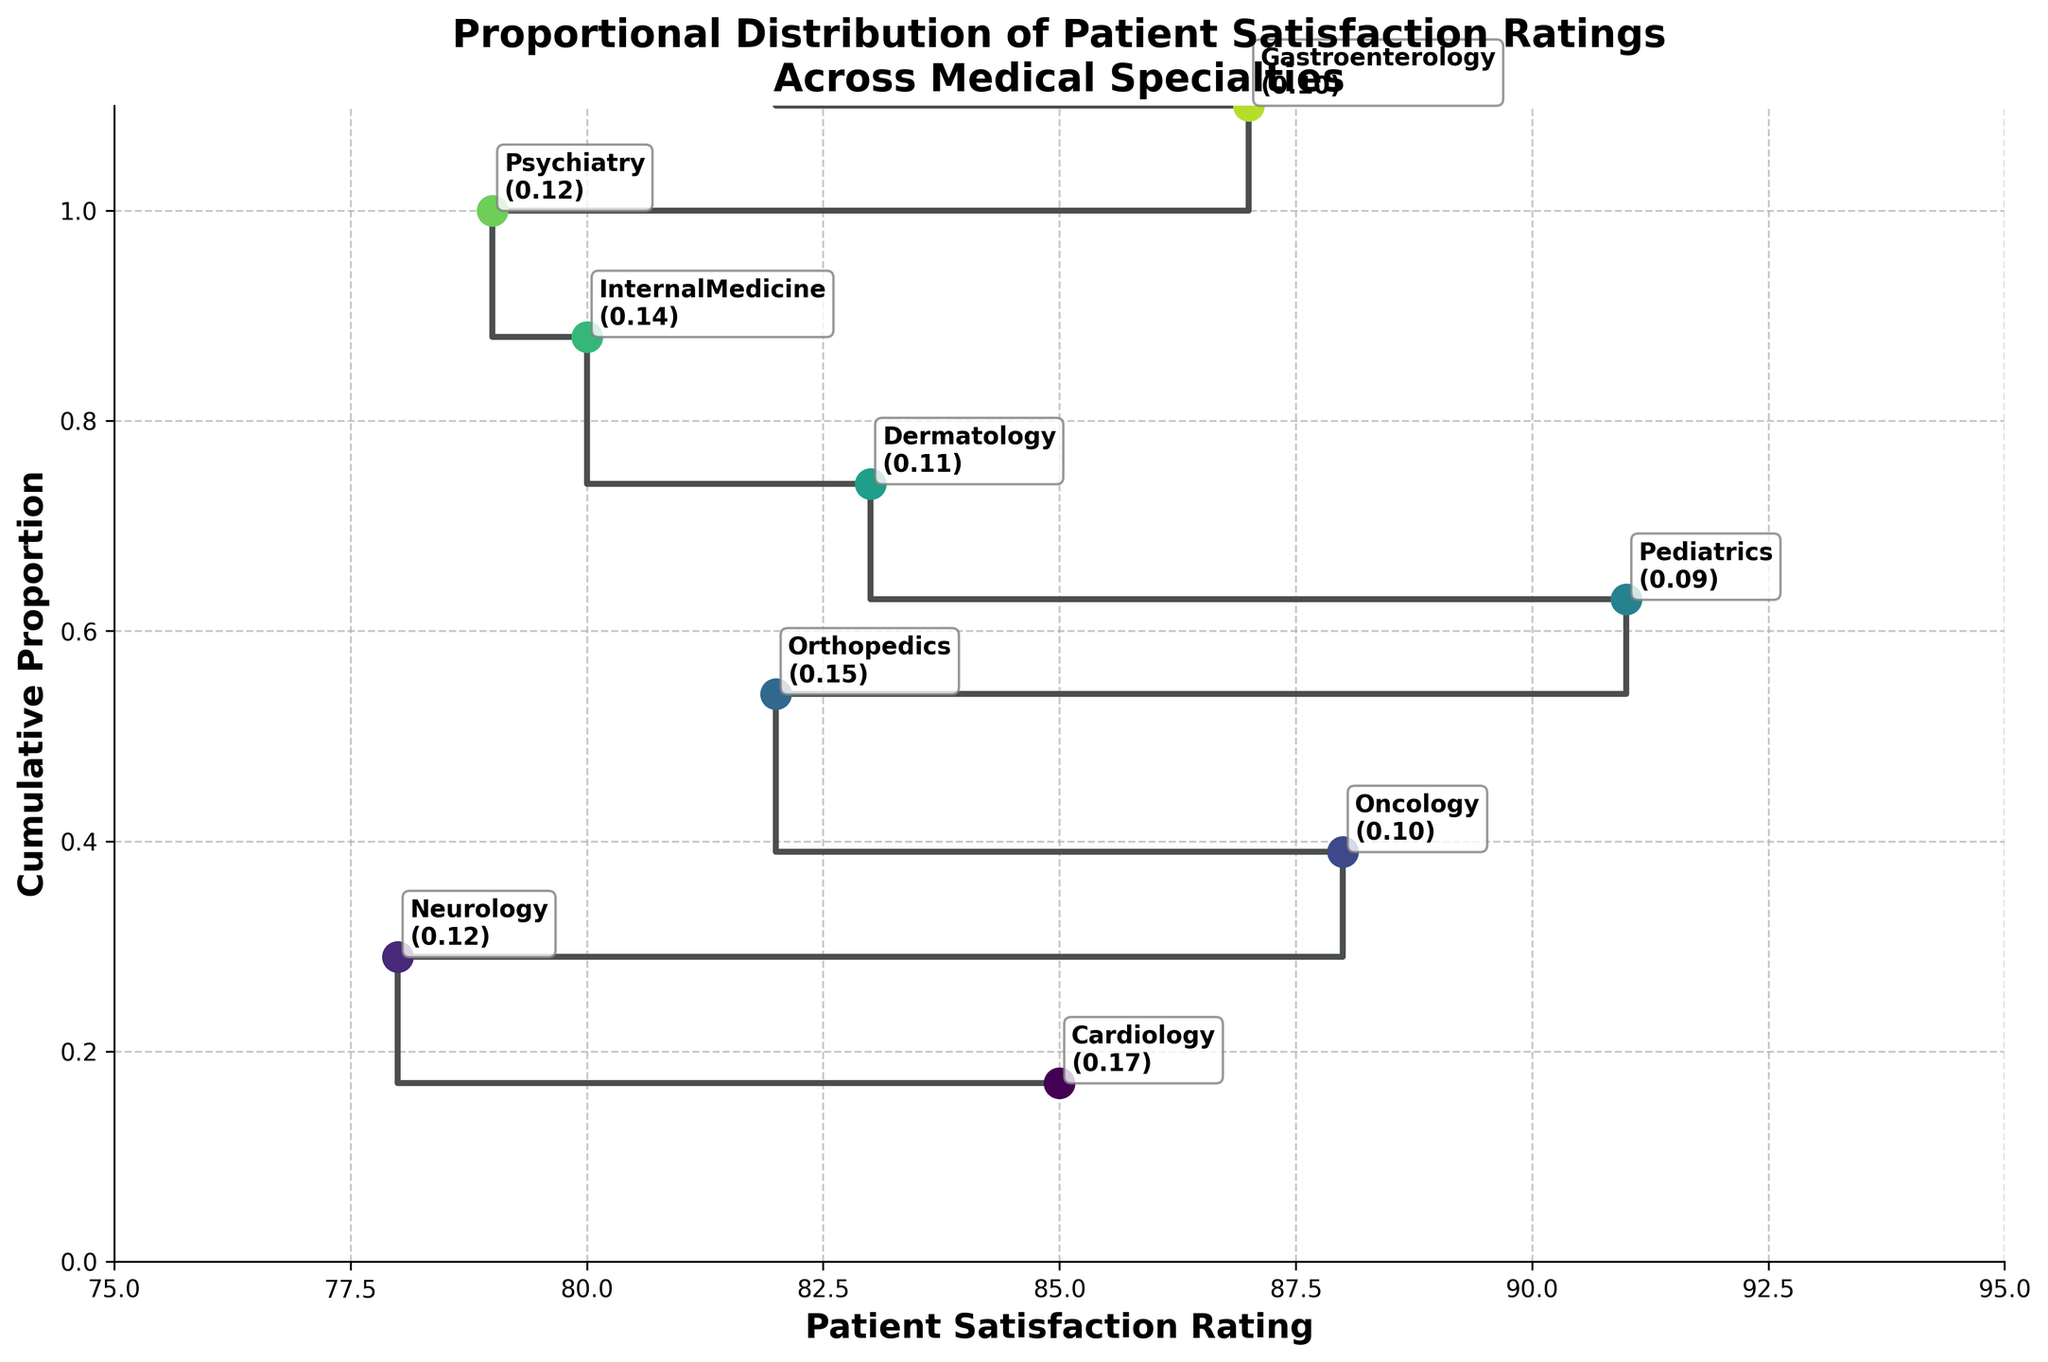What is the title of the plot? The title is located at the top of the plot. It reads: 'Proportional Distribution of Patient Satisfaction Ratings Across Medical Specialties'.
Answer: Proportional Distribution of Patient Satisfaction Ratings Across Medical Specialties Which medical specialty has the highest patient satisfaction rating? The step plot shows the Patient Satisfaction Rating on the x-axis. The highest point on this axis corresponds to Pediatrics with a rating of 91.
Answer: Pediatrics What is the cumulative proportion after adding the Dermatology specialty? Locate Dermatology on the plot, observe its rating, and the corresponding cumulative proportion from the y-axis. Dermatology has a satisfaction rating of 83, with the cumulative proportion being around 0.74.
Answer: 0.74 How many specialties have a satisfaction rating of 82? Observe the x-axis for satisfaction rating 82 and note the number of medical specialties plotted there, which are Orthopedics and Urology, indicating 2 specialties.
Answer: 2 Which specialization immediately follows Neurology in the cumulative proportion? Find the position of Neurology on the plot, then look at the next point in the cumulative proportion plot. The next specialty is Dermatology.
Answer: Dermatology Compare and contrast the patient satisfaction ratings of Neurology and Psychiatry. Which one is higher? Find Neurology and Psychiatry on the x-axis. Neurology has a rating of 78, whereas Psychiatry has a rating of 79. Therefore, Psychiatry has a higher rating.
Answer: Psychiatry What is the cumulative proportion after adding the specialties with ratings greater than 85? Identify specialties with patient satisfaction ratings greater than 85: Cardiology, Oncology, Pediatrics, and Gastroenterology. Sum their proportions: 0.17 (Cardiology) + 0.10 (Oncology) + 0.09 (Pediatrics) + 0.10 (Gastroenterology) = 0.46.
Answer: 0.46 Which medical specialty's proportional distribution ends with a cumulative proportion closest to 0.50? Look at the cumulative distribution on the y-axis. The closest value to 0.50 is that of Orthopedics.
Answer: Orthopedics 